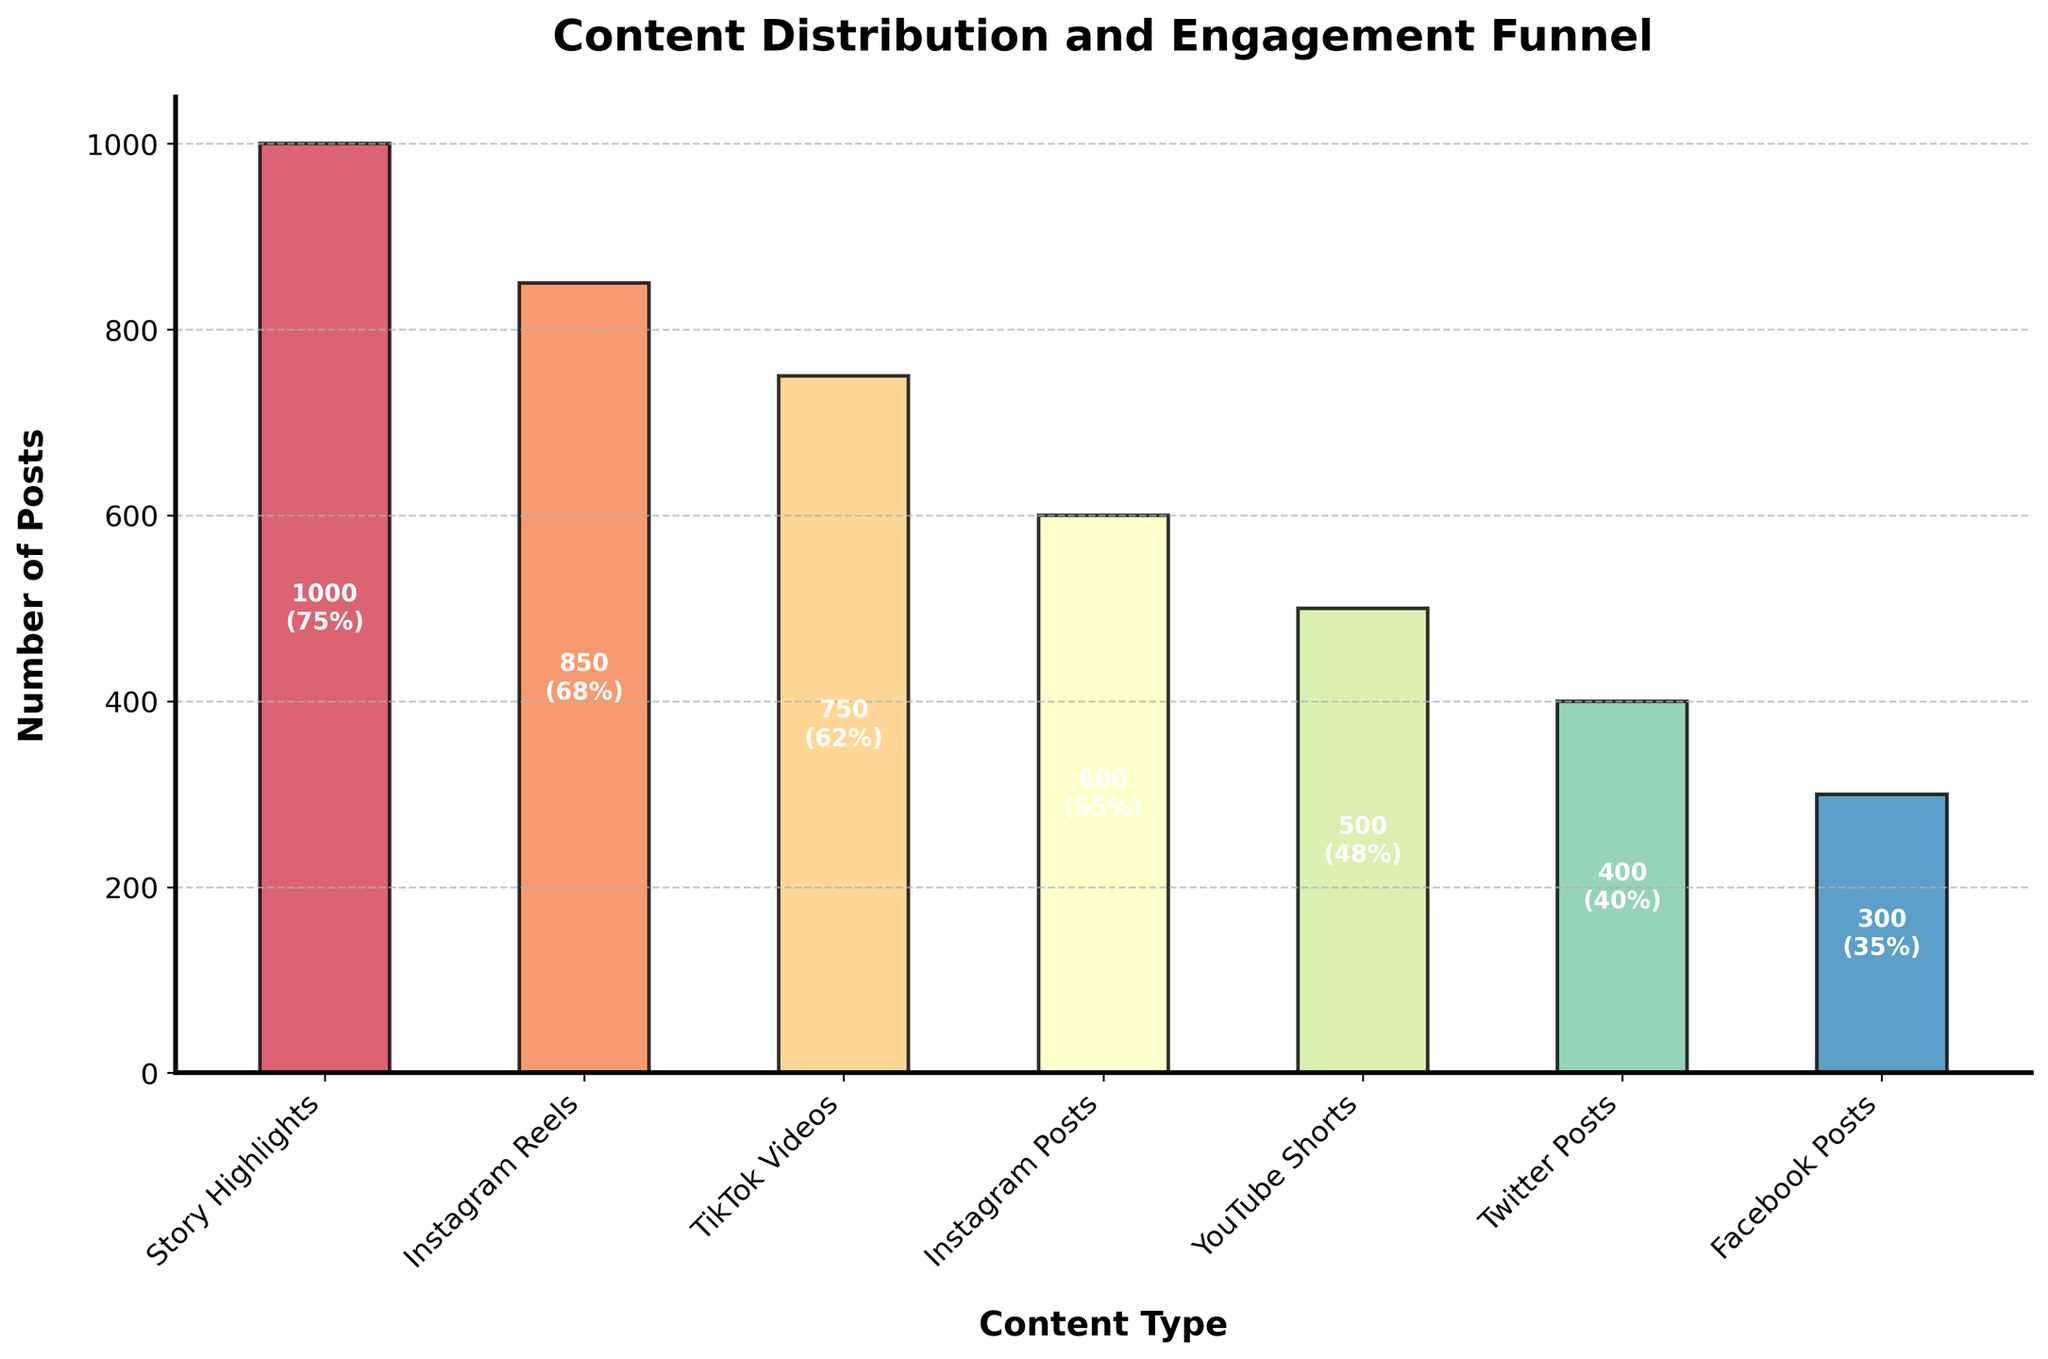What is the title of the plot? The title of the plot is written at the top center of the figure. It visually stands out due to its size and font style, making it clear and noticeable.
Answer: Content Distribution and Engagement Funnel Which content type has the highest engagement rate? Engagement rates are mentioned in parentheses below each bar. The highest engagement rate would be the highest percentage among all types.
Answer: Story Highlights How many YouTube Shorts posts are there? The number of posts for each content type is displayed as text inside the bars. Look for the bar labeled "YouTube Shorts" to find the number.
Answer: 500 What is the total number of posts across all content types? Sum the number of posts for each content type: 1000 + 850 + 750 + 600 + 500 + 400 + 300.
Answer: 4,400 Compare the engagement rates of Instagram Reels and TikTok Videos. Which is higher? Look at the engagement rates in parentheses for "Instagram Reels" and "TikTok Videos". Compare the two percentages.
Answer: Instagram Reels What is the average engagement rate across all content types? Convert the percentages to numbers, sum them, and divide by the total number of content types: (75 + 68 + 62 + 55 + 48 + 40 + 35) / 7.
Answer: 54.7% Between Twitter Posts and Facebook Posts, which has fewer posts and what is the difference? Check the number of posts for "Twitter Posts" and "Facebook Posts" written inside the bars and subtract the smaller number from the larger.
Answer: Facebook Posts, 100 Arrange the content types in descending order of their number of posts. Read the number of posts inside each bar and list the content types from the highest to the lowest: Story Highlights, Instagram Reels, TikTok Videos, Instagram Posts, YouTube Shorts, Twitter Posts, Facebook Posts.
Answer: Story Highlights, Instagram Reels, TikTok Videos, Instagram Posts, YouTube Shorts, Twitter Posts, Facebook Posts What is the difference in engagement rates between the highest and lowest content types? Identify the highest (Story Highlights) and lowest (Facebook Posts) engagement rates and subtract the lower percentage from the higher: 75% - 35%.
Answer: 40% Is the engagement rate always directly proportional to the number of posts for the content types? Examine if higher engagement rates correspond to higher numbers of posts by visually comparing the heights of the bars and their engagement percentages.
Answer: No 